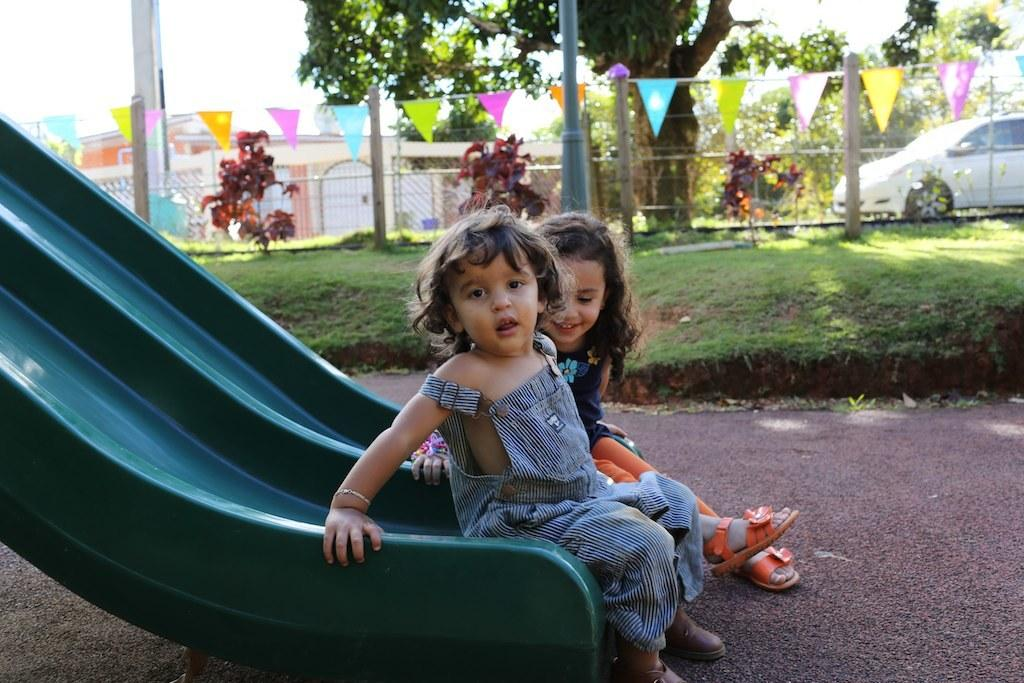How many kids are in the image? There are two kids in the image. What are the kids doing in the image? The kids are sitting on a slider. What type of surface can be seen beneath the kids? There is grass in the image. What can be seen in the background of the image? There are trees, houses, and a parked car in the background of the image. What is the condition of the sky in the image? The sky is clear in the image. Where is the mailbox located in the image? There is no mailbox present in the image. What type of tent can be seen in the image? There is no tent present in the image. 